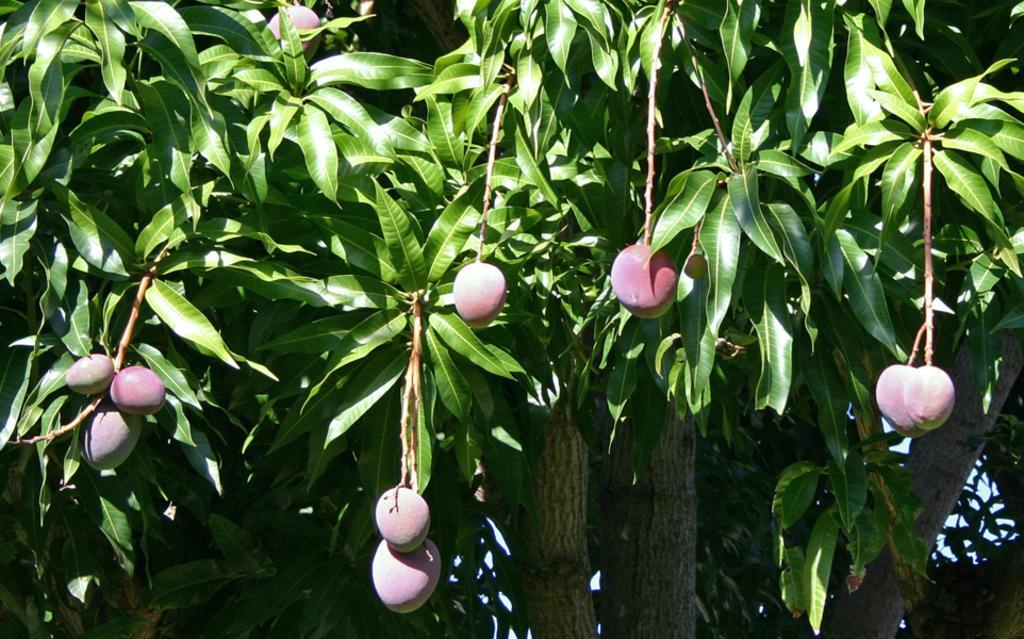In one or two sentences, can you explain what this image depicts? In this image we can see a tree with the branches and also mangoes. 